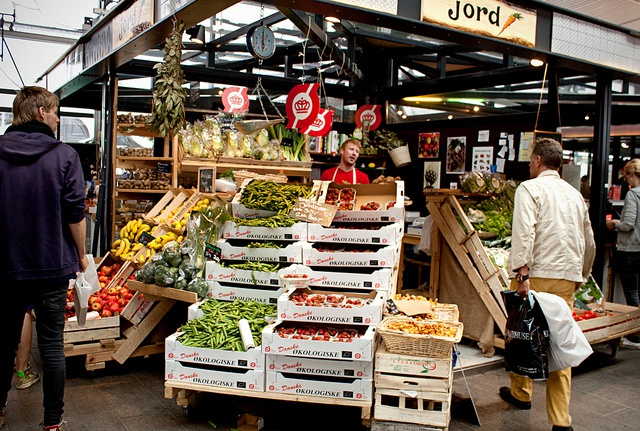Describe the objects in this image and their specific colors. I can see people in lightgray, black, gray, and purple tones, people in lightgray, ivory, and tan tones, handbag in lightgray, black, gray, maroon, and teal tones, people in lightgray, black, gray, darkgray, and maroon tones, and people in lightgray, red, brown, and maroon tones in this image. 